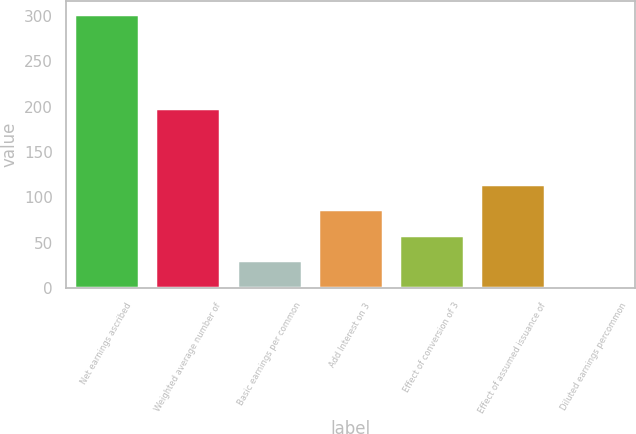<chart> <loc_0><loc_0><loc_500><loc_500><bar_chart><fcel>Net earnings ascribed<fcel>Weighted average number of<fcel>Basic earnings per common<fcel>Add Interest on 3<fcel>Effect of conversion of 3<fcel>Effect of assumed issuance of<fcel>Diluted earnings percommon<nl><fcel>302<fcel>198.23<fcel>30.83<fcel>86.63<fcel>58.73<fcel>114.53<fcel>2.93<nl></chart> 